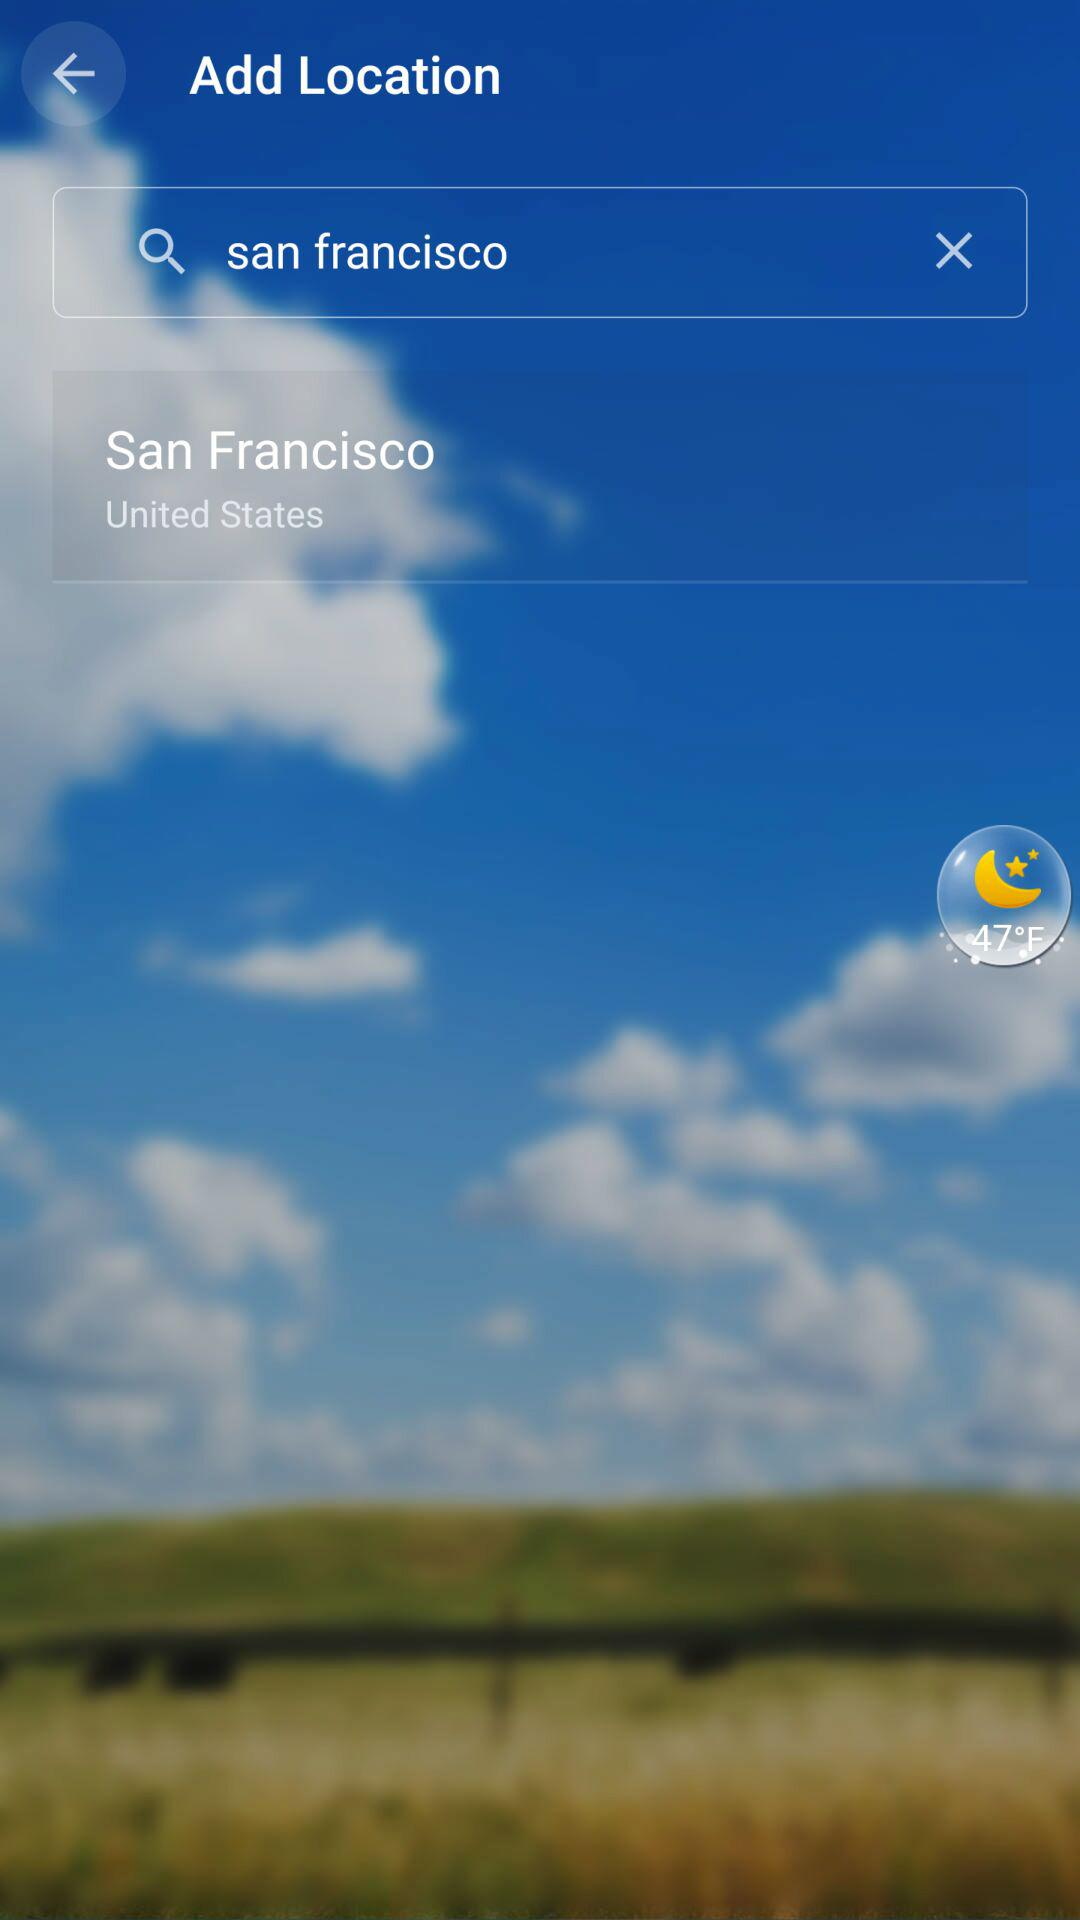How many degrees Fahrenheit is the current temperature?
Answer the question using a single word or phrase. 47°F 